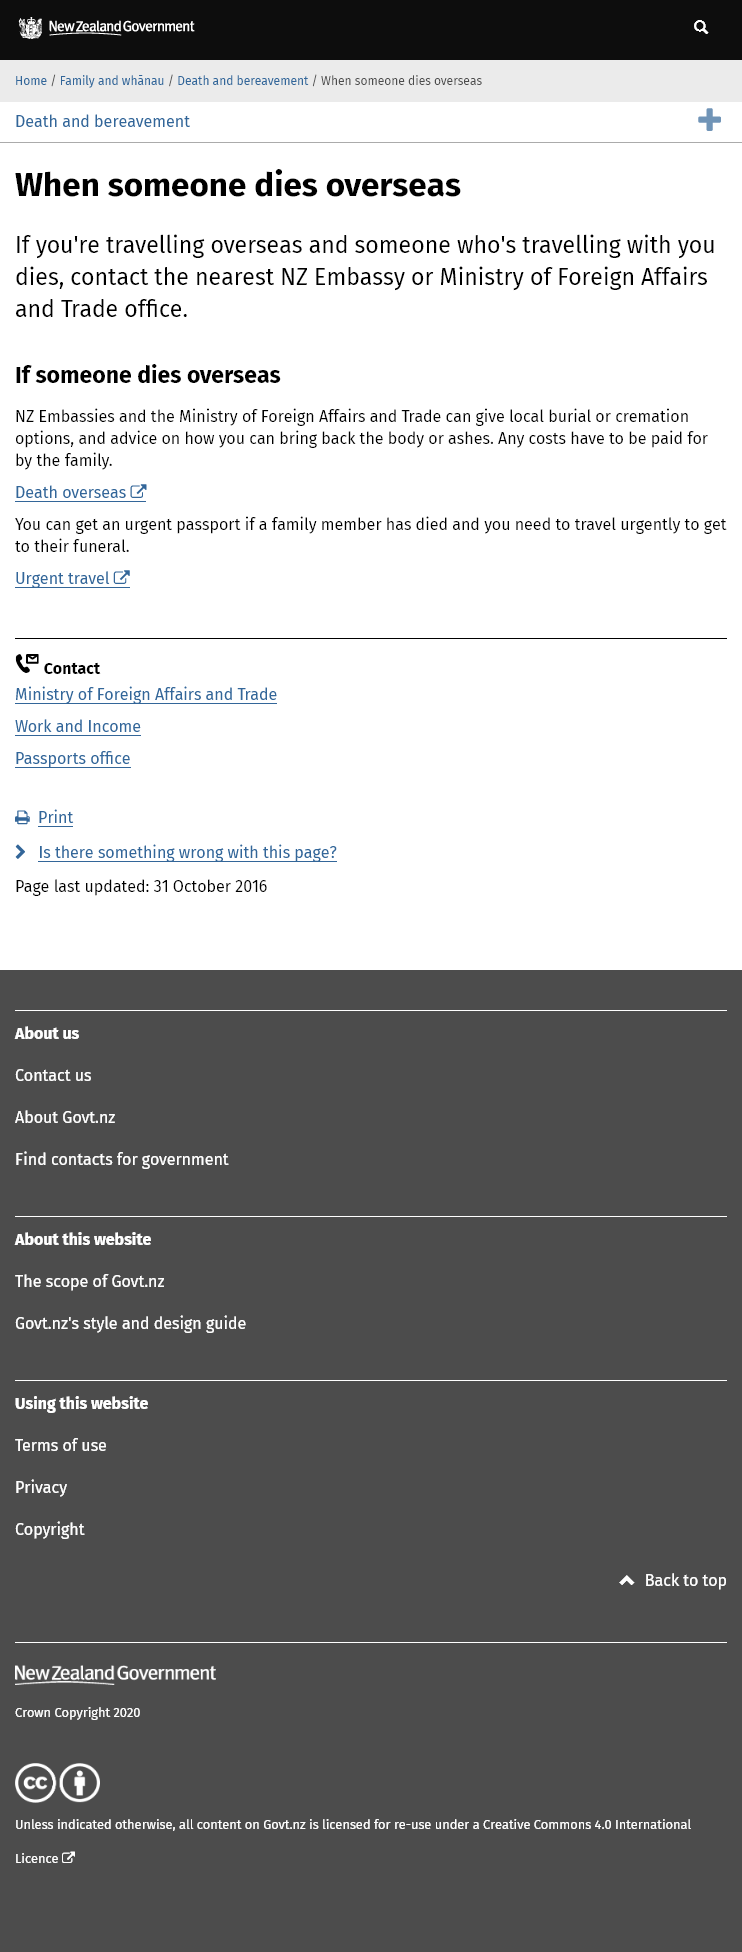Draw attention to some important aspects in this diagram. If someone you are travelling with overseas dies, you should contact the nearest New Zealand Embassy or Ministry of Foreign Affairs and Trade Office. The NZ Embassies and the Ministry of Foreign Affairs and Trade can provide local burial or cremation options and issue urgent passports for travel to a family member's funeral in the event of their death. The family is responsible for paying the costs associated with burying or cremating someone who dies overseas. 